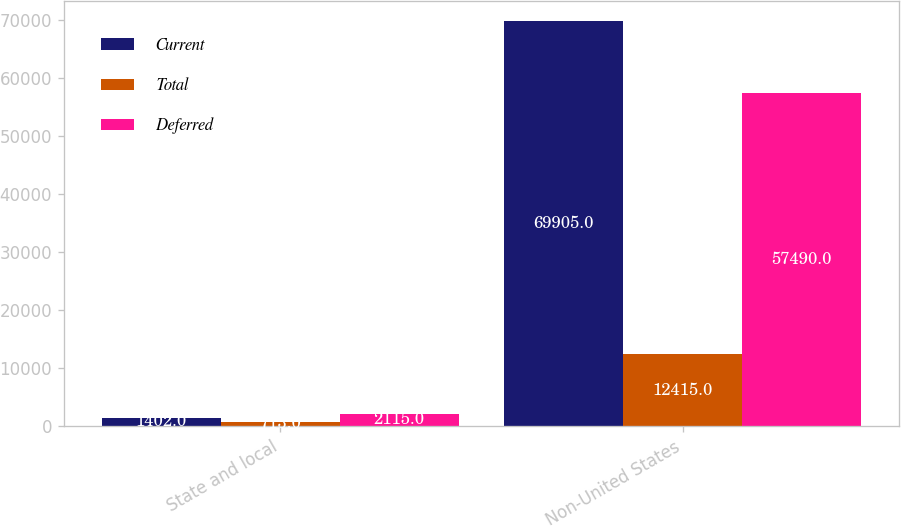Convert chart. <chart><loc_0><loc_0><loc_500><loc_500><stacked_bar_chart><ecel><fcel>State and local<fcel>Non-United States<nl><fcel>Current<fcel>1402<fcel>69905<nl><fcel>Total<fcel>713<fcel>12415<nl><fcel>Deferred<fcel>2115<fcel>57490<nl></chart> 